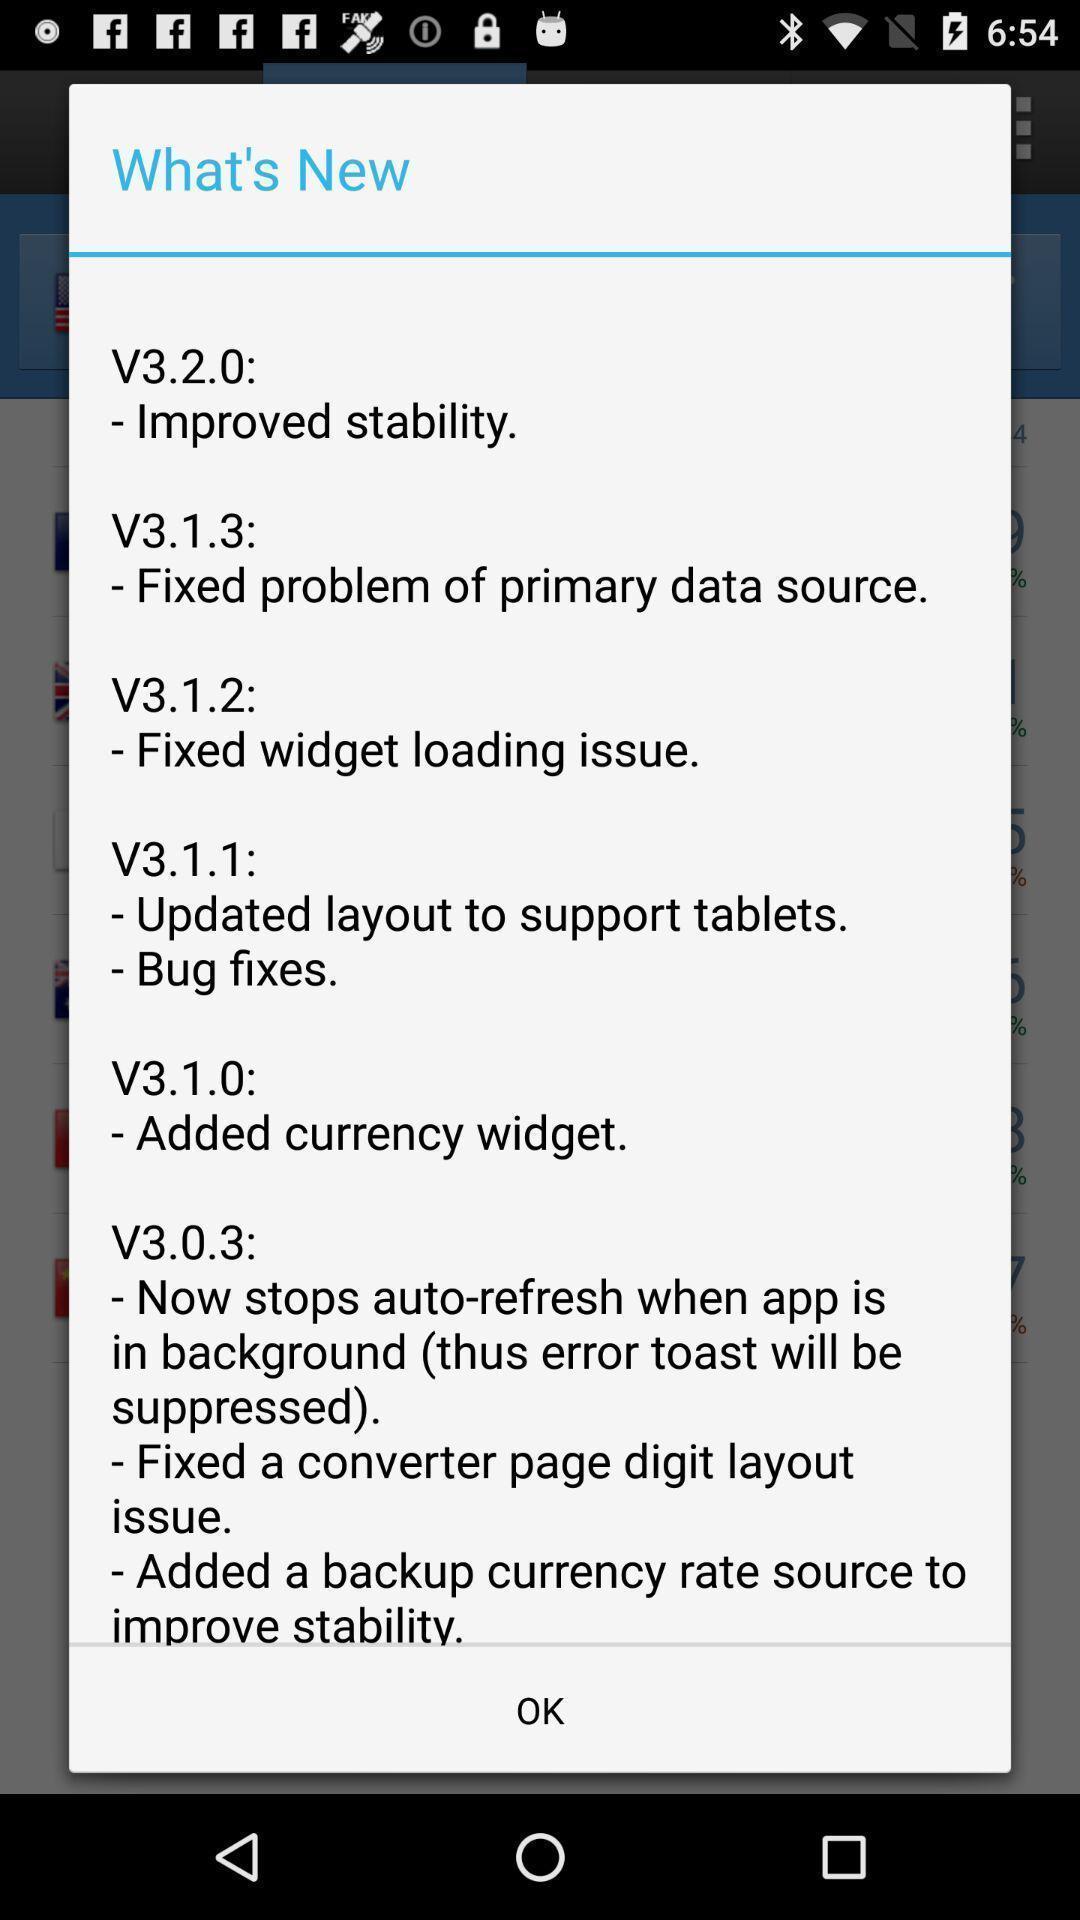Explain the elements present in this screenshot. Pop-up showing info in a currency converter app. 